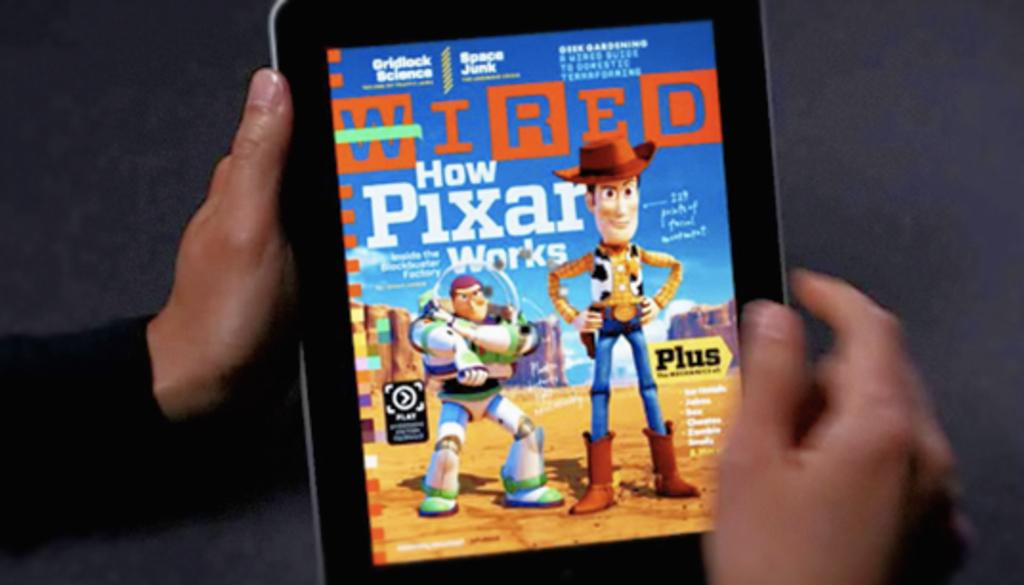<image>
Describe the image concisely. The magazine cover of Wired is displayed on a tablet 